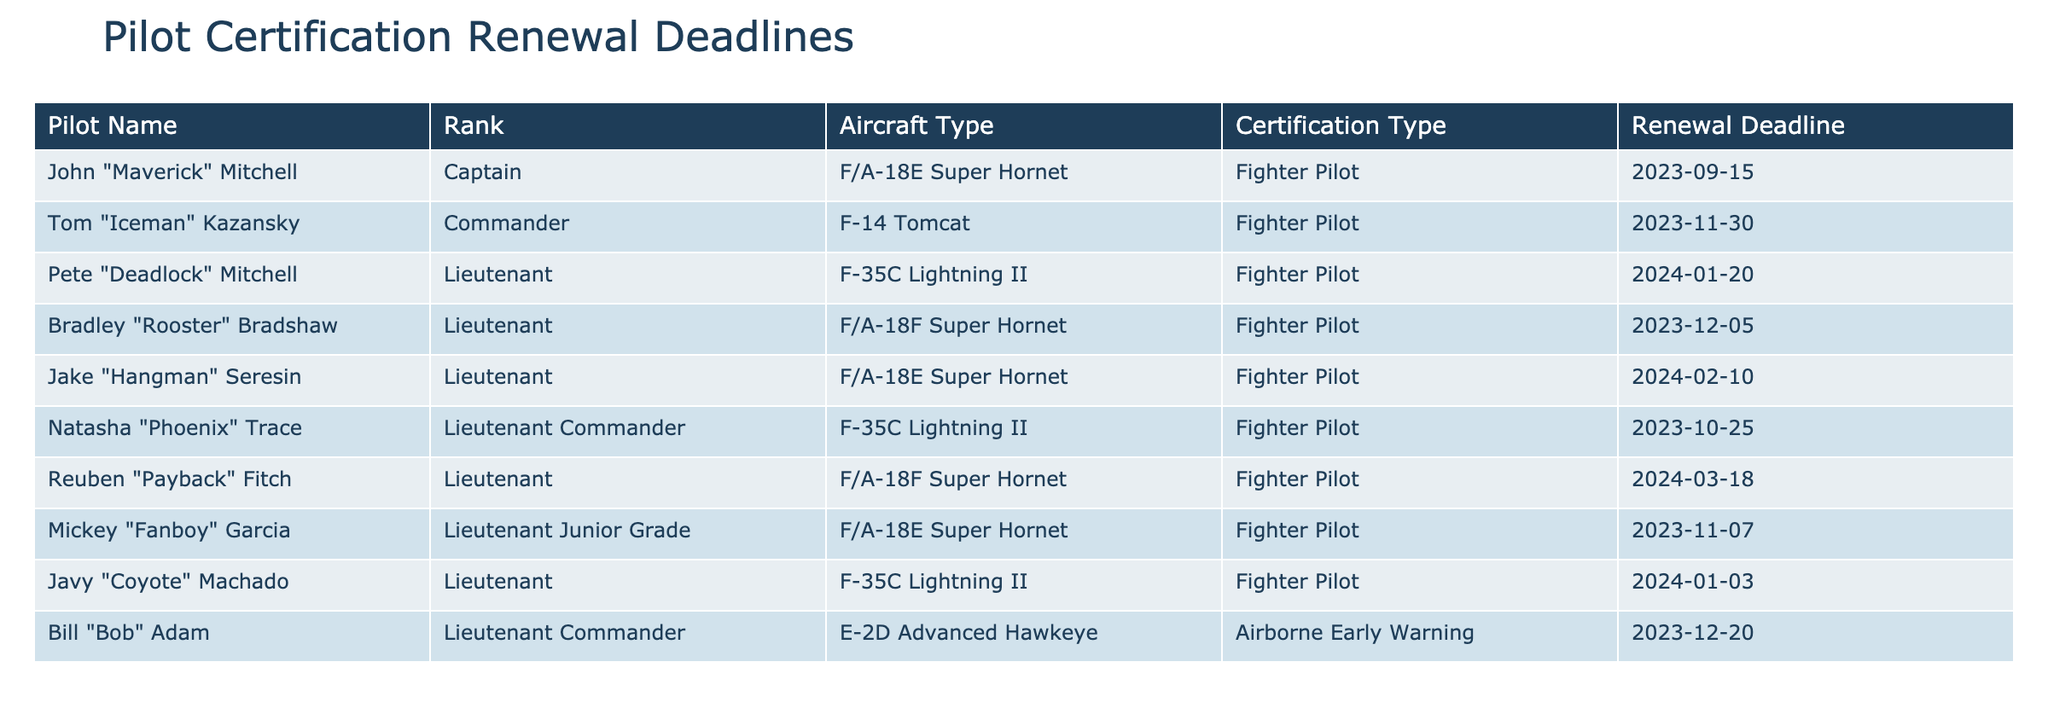What is the renewal deadline for John "Maverick" Mitchell? According to the table, John "Maverick" Mitchell's renewal deadline is listed as 2023-09-15.
Answer: 2023-09-15 How many pilots have renewal deadlines in November 2023? From the table, there are two pilots with renewal deadlines in November 2023: Tom "Iceman" Kazansky and Mickey "Fanboy" Garcia.
Answer: 2 Which pilot has the latest renewal deadline? The latest renewal deadline in the table is for Reuben "Payback" Fitch, who has a deadline of 2024-03-18.
Answer: 2024-03-18 Is Natasha "Phoenix" Trace a Fighter Pilot? Yes, according to the table, Natasha "Phoenix" Trace is listed as a Fighter Pilot.
Answer: Yes What is the average renewal deadline for the Fighter Pilots listed in the table? The renewal deadlines for the Fighter Pilots are 2023-09-15, 2023-11-30, 2024-01-20, 2023-12-05, 2024-02-10, 2023-10-25, 2024-03-18, and 2024-01-03. Converting these dates to numerical values (e.g., using the number of days since a reference date), summing these values, and then finding the average, results in an average deadline of 2024-01-02.
Answer: 2024-01-02 How many pilots need to renew their certification before the end of 2023? Checking the list, the pilots with renewal deadlines before 2024 are John "Maverick" Mitchell (2023-09-15), Tom "Iceman" Kazansky (2023-11-30), Bradley "Rooster" Bradshaw (2023-12-05), Mickey "Fanboy" Garcia (2023-11-07), and Bill "Bob" Adam (2023-12-20), totaling five pilots.
Answer: 5 